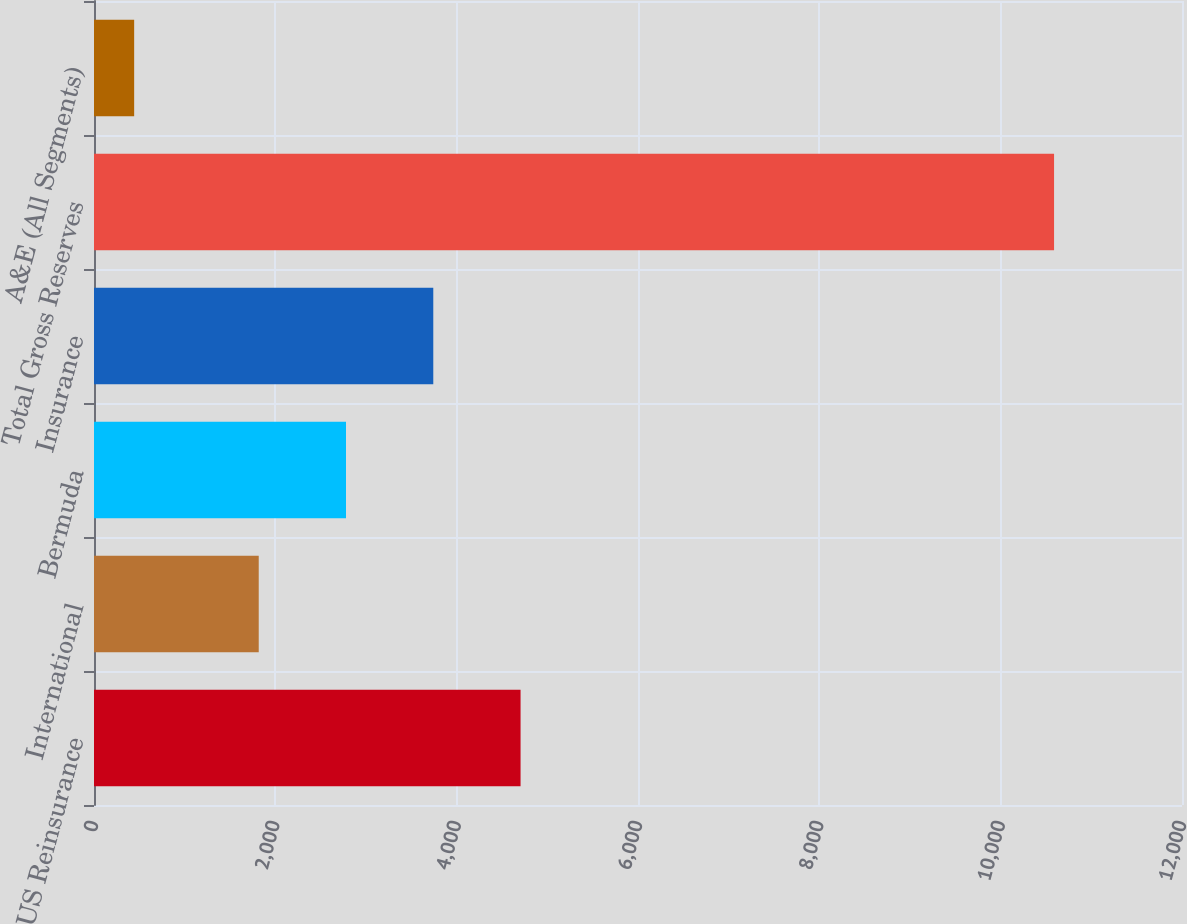Convert chart to OTSL. <chart><loc_0><loc_0><loc_500><loc_500><bar_chart><fcel>US Reinsurance<fcel>International<fcel>Bermuda<fcel>Insurance<fcel>Total Gross Reserves<fcel>A&E (All Segments)<nl><fcel>4704.66<fcel>1816.8<fcel>2779.42<fcel>3742.04<fcel>10588.8<fcel>442.9<nl></chart> 